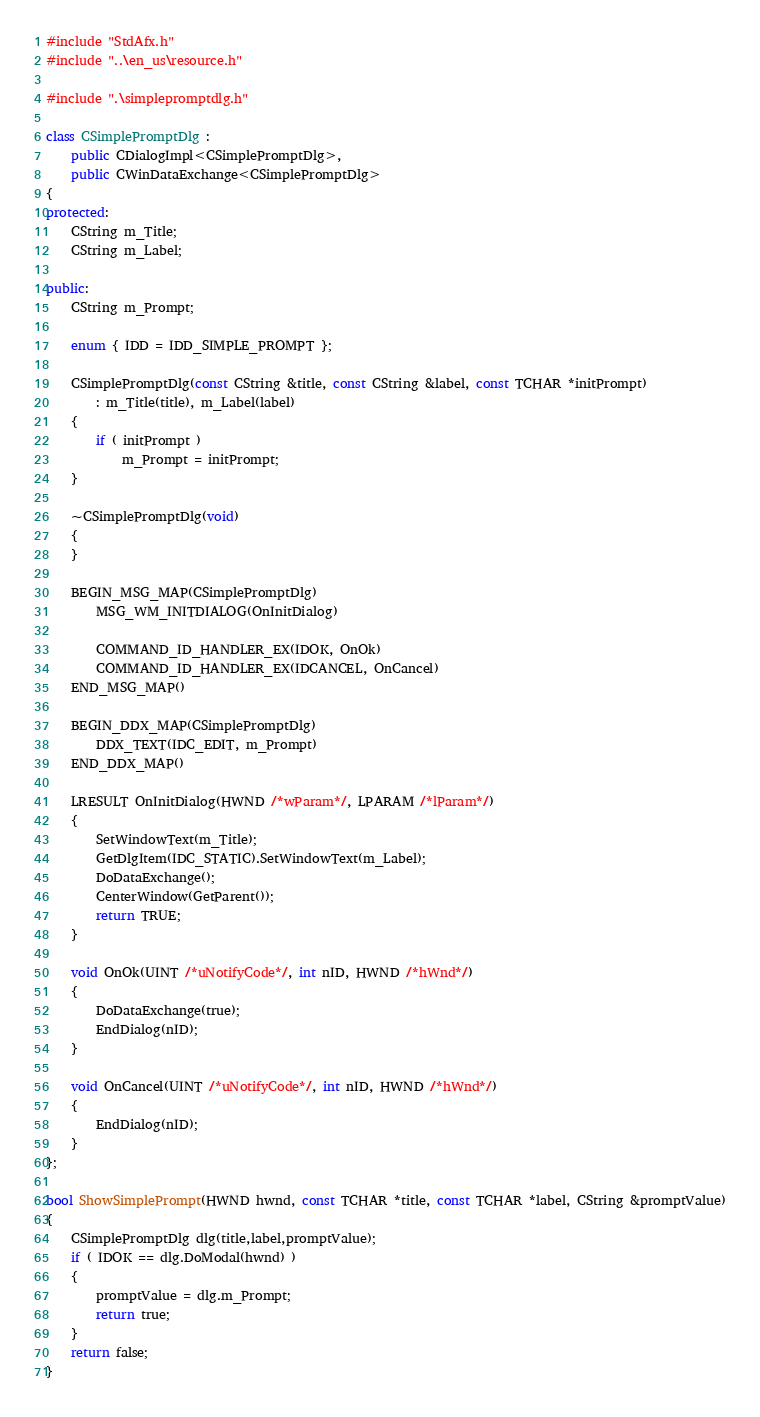<code> <loc_0><loc_0><loc_500><loc_500><_C++_>#include "StdAfx.h"
#include "..\en_us\resource.h"

#include ".\simplepromptdlg.h"

class CSimplePromptDlg : 
	public CDialogImpl<CSimplePromptDlg>, 
	public CWinDataExchange<CSimplePromptDlg>
{
protected:
	CString m_Title;
	CString m_Label;

public:
	CString m_Prompt;

	enum { IDD = IDD_SIMPLE_PROMPT };

	CSimplePromptDlg(const CString &title, const CString &label, const TCHAR *initPrompt)
		: m_Title(title), m_Label(label)
	{
		if ( initPrompt )
			m_Prompt = initPrompt;
	}

	~CSimplePromptDlg(void)
	{
	}

	BEGIN_MSG_MAP(CSimplePromptDlg)
		MSG_WM_INITDIALOG(OnInitDialog)

		COMMAND_ID_HANDLER_EX(IDOK, OnOk)
		COMMAND_ID_HANDLER_EX(IDCANCEL, OnCancel)
	END_MSG_MAP()

	BEGIN_DDX_MAP(CSimplePromptDlg)
		DDX_TEXT(IDC_EDIT, m_Prompt)
	END_DDX_MAP()

	LRESULT OnInitDialog(HWND /*wParam*/, LPARAM /*lParam*/)
	{
		SetWindowText(m_Title);
		GetDlgItem(IDC_STATIC).SetWindowText(m_Label);
		DoDataExchange();
		CenterWindow(GetParent());
		return TRUE;
	}

	void OnOk(UINT /*uNotifyCode*/, int nID, HWND /*hWnd*/)
	{
		DoDataExchange(true);
		EndDialog(nID);
	}

	void OnCancel(UINT /*uNotifyCode*/, int nID, HWND /*hWnd*/)
	{
		EndDialog(nID);
	}
};

bool ShowSimplePrompt(HWND hwnd, const TCHAR *title, const TCHAR *label, CString &promptValue)
{
	CSimplePromptDlg dlg(title,label,promptValue);
	if ( IDOK == dlg.DoModal(hwnd) )
	{
		promptValue = dlg.m_Prompt;
		return true;
	}
	return false;
}
</code> 